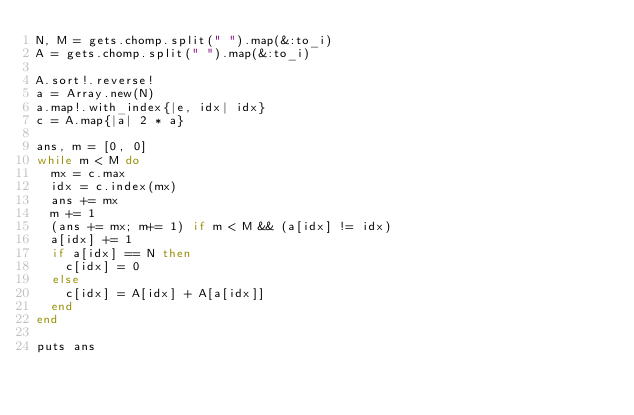<code> <loc_0><loc_0><loc_500><loc_500><_Ruby_>N, M = gets.chomp.split(" ").map(&:to_i)
A = gets.chomp.split(" ").map(&:to_i)

A.sort!.reverse!
a = Array.new(N)
a.map!.with_index{|e, idx| idx}
c = A.map{|a| 2 * a}

ans, m = [0, 0]
while m < M do
  mx = c.max
  idx = c.index(mx)
  ans += mx
  m += 1
  (ans += mx; m+= 1) if m < M && (a[idx] != idx)
  a[idx] += 1
  if a[idx] == N then
    c[idx] = 0
  else
    c[idx] = A[idx] + A[a[idx]]
  end
end

puts ans
</code> 